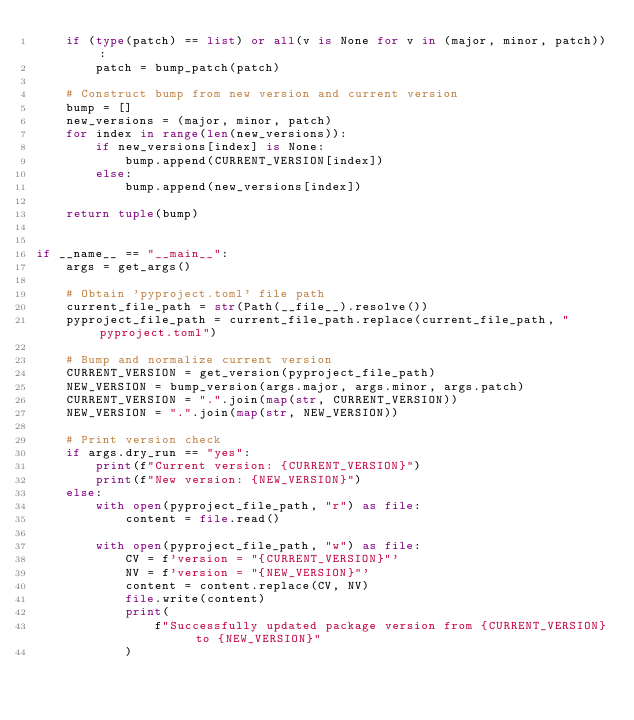Convert code to text. <code><loc_0><loc_0><loc_500><loc_500><_Python_>    if (type(patch) == list) or all(v is None for v in (major, minor, patch)):
        patch = bump_patch(patch)

    # Construct bump from new version and current version
    bump = []
    new_versions = (major, minor, patch)
    for index in range(len(new_versions)):
        if new_versions[index] is None:
            bump.append(CURRENT_VERSION[index])
        else:
            bump.append(new_versions[index])

    return tuple(bump)


if __name__ == "__main__":
    args = get_args()

    # Obtain 'pyproject.toml' file path
    current_file_path = str(Path(__file__).resolve())
    pyproject_file_path = current_file_path.replace(current_file_path, "pyproject.toml")

    # Bump and normalize current version
    CURRENT_VERSION = get_version(pyproject_file_path)
    NEW_VERSION = bump_version(args.major, args.minor, args.patch)
    CURRENT_VERSION = ".".join(map(str, CURRENT_VERSION))
    NEW_VERSION = ".".join(map(str, NEW_VERSION))

    # Print version check
    if args.dry_run == "yes":
        print(f"Current version: {CURRENT_VERSION}")
        print(f"New version: {NEW_VERSION}")
    else:
        with open(pyproject_file_path, "r") as file:
            content = file.read()

        with open(pyproject_file_path, "w") as file:
            CV = f'version = "{CURRENT_VERSION}"'
            NV = f'version = "{NEW_VERSION}"'
            content = content.replace(CV, NV)
            file.write(content)
            print(
                f"Successfully updated package version from {CURRENT_VERSION} to {NEW_VERSION}"
            )
</code> 